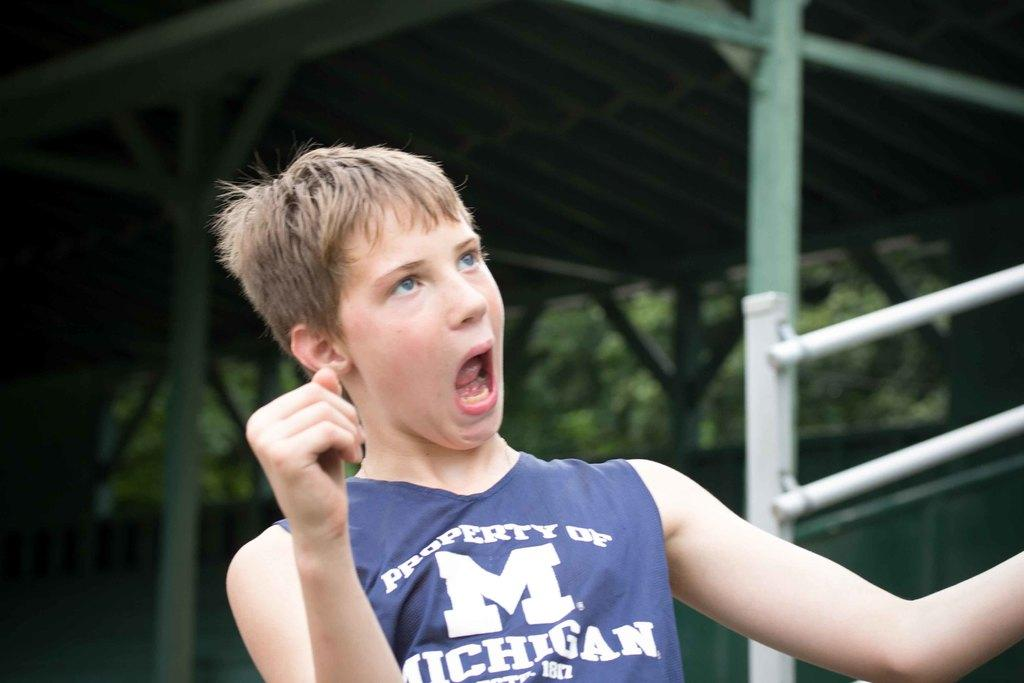<image>
Write a terse but informative summary of the picture. Property of Michigan is embroidered on the tank top of this child. 